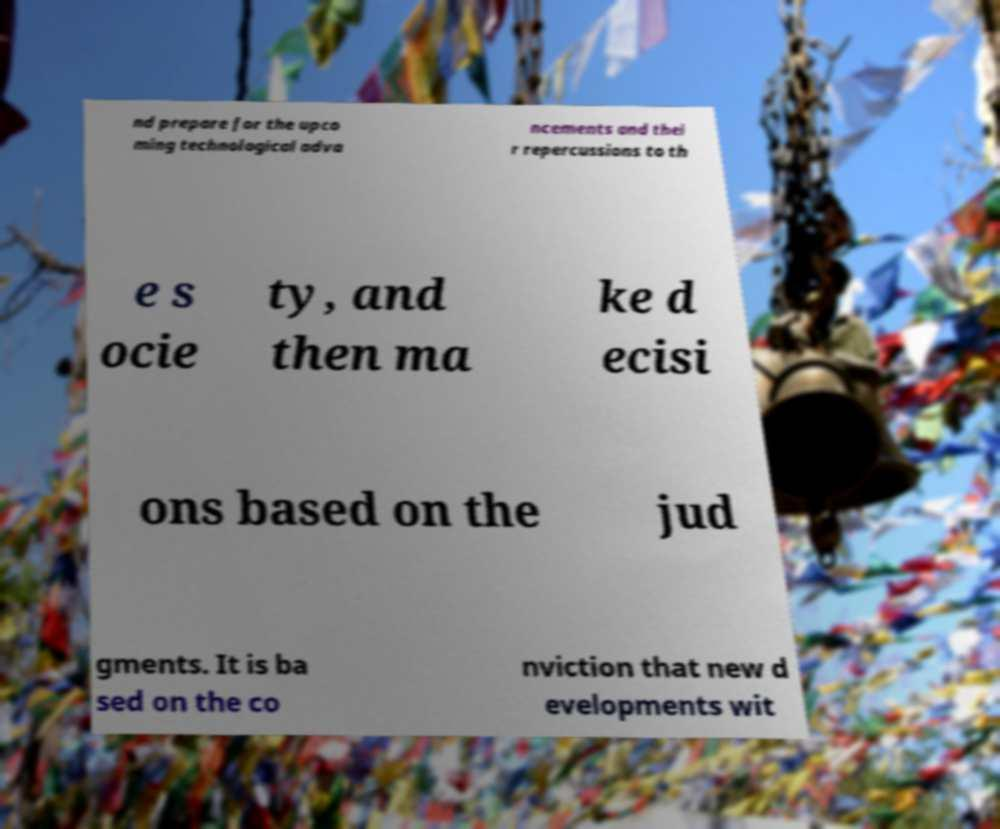Can you read and provide the text displayed in the image?This photo seems to have some interesting text. Can you extract and type it out for me? nd prepare for the upco ming technological adva ncements and thei r repercussions to th e s ocie ty, and then ma ke d ecisi ons based on the jud gments. It is ba sed on the co nviction that new d evelopments wit 